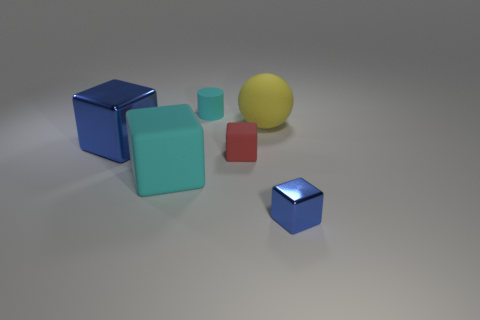What is the size of the metal thing that is the same color as the large metallic cube?
Offer a terse response. Small. What number of matte cubes are behind the big rubber block and in front of the small red rubber block?
Offer a very short reply. 0. There is a cyan thing that is behind the red block; what is its material?
Give a very brief answer. Rubber. There is a cyan block that is made of the same material as the sphere; what size is it?
Provide a short and direct response. Large. The other shiny thing that is the same shape as the tiny shiny object is what size?
Make the answer very short. Large. Does the small metallic object have the same color as the thing to the left of the large cyan cube?
Provide a short and direct response. Yes. Do the small matte cylinder and the large rubber block have the same color?
Your answer should be very brief. Yes. Does the large cube on the left side of the large cyan rubber block have the same material as the yellow sphere?
Provide a short and direct response. No. There is a blue metal object that is behind the metallic block right of the large thing left of the big cyan object; what is its shape?
Make the answer very short. Cube. Are there any blue metal things that have the same size as the cylinder?
Your answer should be very brief. Yes. 